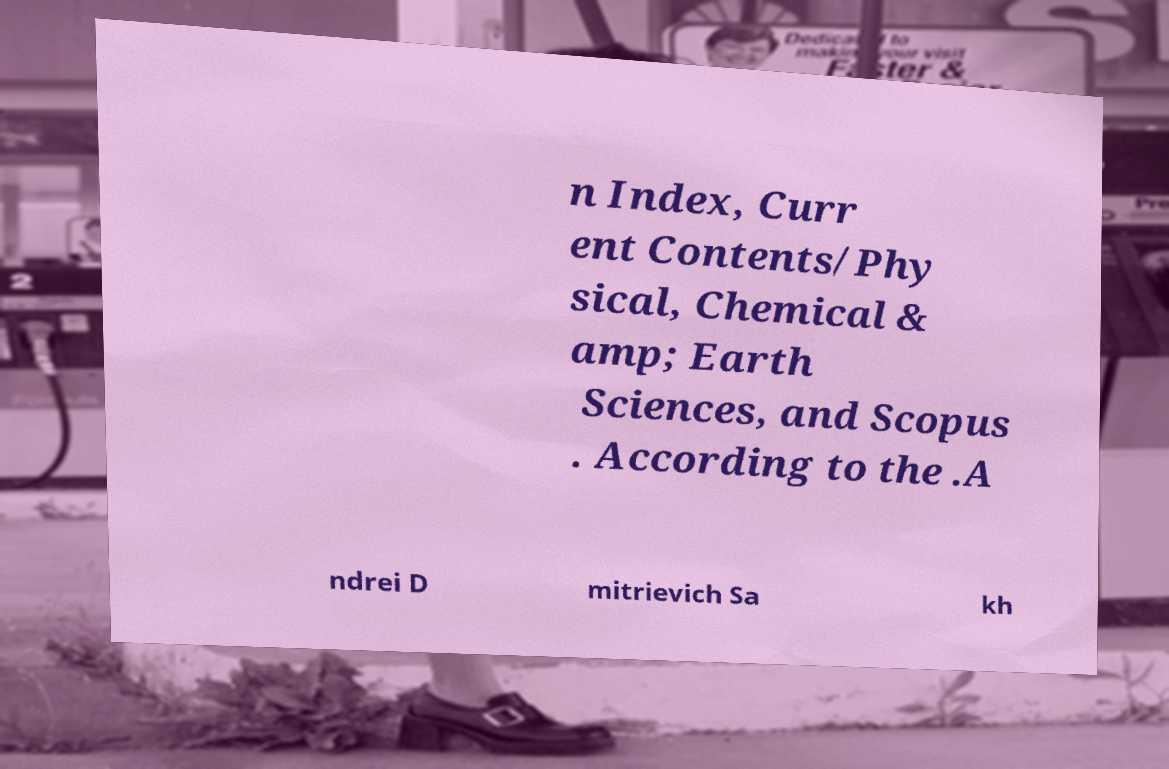Please identify and transcribe the text found in this image. n Index, Curr ent Contents/Phy sical, Chemical & amp; Earth Sciences, and Scopus . According to the .A ndrei D mitrievich Sa kh 